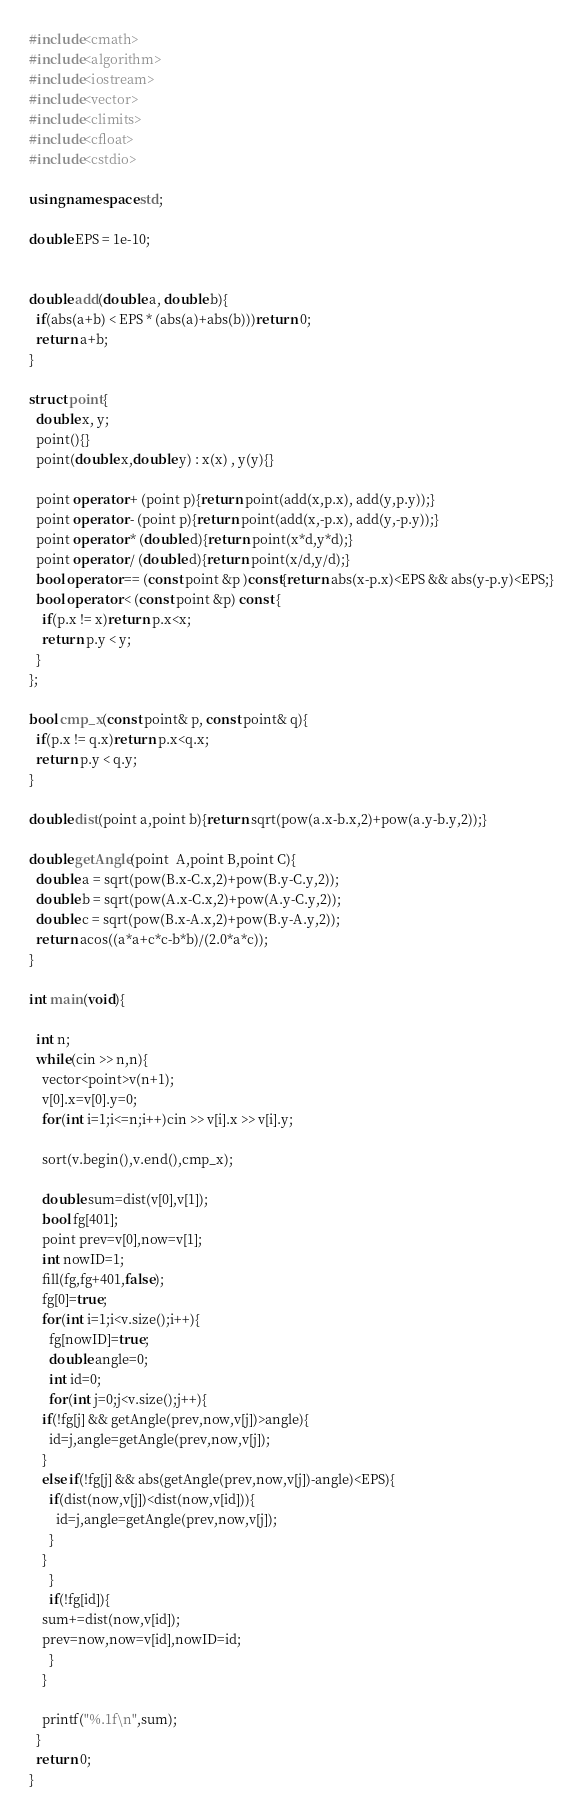<code> <loc_0><loc_0><loc_500><loc_500><_C++_>#include<cmath>
#include<algorithm>
#include<iostream>
#include<vector>
#include<climits>
#include<cfloat>
#include<cstdio>

using namespace std;

double EPS = 1e-10;


double add(double a, double b){
  if(abs(a+b) < EPS * (abs(a)+abs(b)))return 0;
  return a+b;
}

struct point{
  double x, y;
  point(){}
  point(double x,double y) : x(x) , y(y){}

  point operator + (point p){return point(add(x,p.x), add(y,p.y));}
  point operator - (point p){return point(add(x,-p.x), add(y,-p.y));}
  point operator * (double d){return point(x*d,y*d);}
  point operator / (double d){return point(x/d,y/d);}
  bool operator == (const point &p )const{return abs(x-p.x)<EPS && abs(y-p.y)<EPS;}
  bool operator < (const point &p) const {
    if(p.x != x)return p.x<x;
    return p.y < y;
  }
};

bool cmp_x(const point& p, const point& q){
  if(p.x != q.x)return p.x<q.x;
  return p.y < q.y;
}

double dist(point a,point b){return sqrt(pow(a.x-b.x,2)+pow(a.y-b.y,2));}
 
double getAngle(point  A,point B,point C){
  double a = sqrt(pow(B.x-C.x,2)+pow(B.y-C.y,2));
  double b = sqrt(pow(A.x-C.x,2)+pow(A.y-C.y,2));
  double c = sqrt(pow(B.x-A.x,2)+pow(B.y-A.y,2));
  return acos((a*a+c*c-b*b)/(2.0*a*c));
}
 
int main(void){

  int n;
  while(cin >> n,n){
    vector<point>v(n+1);
    v[0].x=v[0].y=0;
    for(int i=1;i<=n;i++)cin >> v[i].x >> v[i].y;
    
    sort(v.begin(),v.end(),cmp_x);    

    double sum=dist(v[0],v[1]);
    bool fg[401];
    point prev=v[0],now=v[1];
    int nowID=1;
    fill(fg,fg+401,false);
    fg[0]=true;
    for(int i=1;i<v.size();i++){
      fg[nowID]=true;
      double angle=0;
      int id=0;
      for(int j=0;j<v.size();j++){
	if(!fg[j] && getAngle(prev,now,v[j])>angle){
	  id=j,angle=getAngle(prev,now,v[j]);
	}
	else if(!fg[j] && abs(getAngle(prev,now,v[j])-angle)<EPS){
	  if(dist(now,v[j])<dist(now,v[id])){
	    id=j,angle=getAngle(prev,now,v[j]);
	  }
	}
      }
      if(!fg[id]){
	sum+=dist(now,v[id]);
	prev=now,now=v[id],nowID=id;
      }
    }

    printf("%.1f\n",sum);
  }
  return 0;
}</code> 